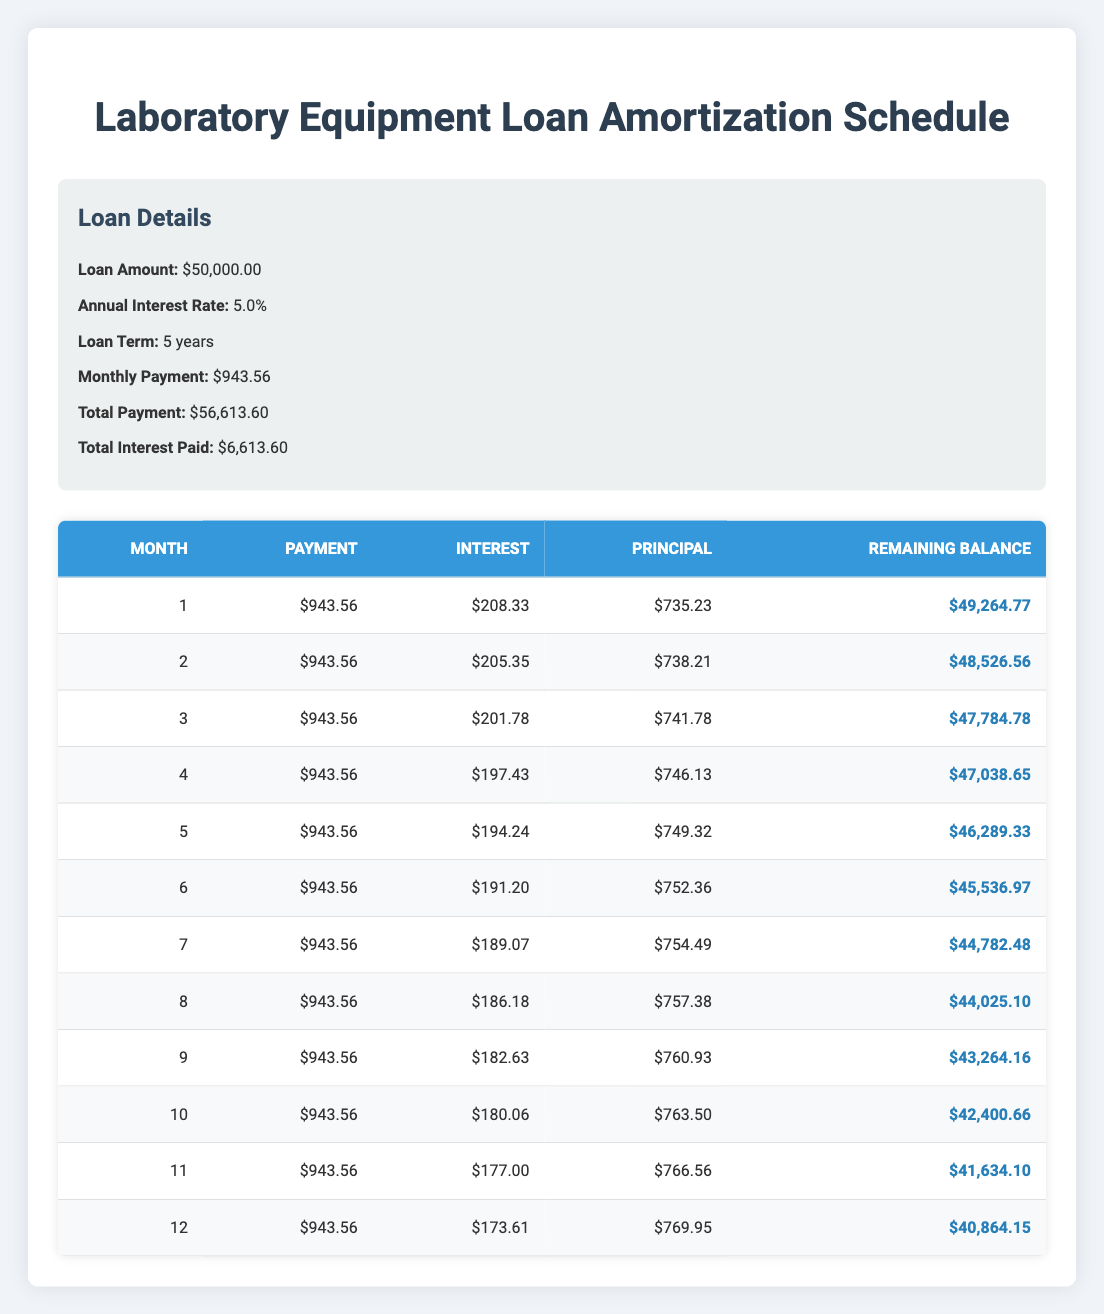What is the total loan amount? The total loan amount is specified in the loan details section, which states that the loan amount is 50,000.00.
Answer: 50,000.00 How much is the monthly payment? The monthly payment is listed in the loan details section, where it explicitly states that the monthly payment is 943.56.
Answer: 943.56 What was the interest paid in the 3rd month? Looking at the amortization schedule for the 3rd month, the interest paid is listed as 201.78.
Answer: 201.78 What is the remaining balance after the first payment? The remaining balance after the first payment can be found in the first row of the amortization schedule, which indicates it is 49,264.77.
Answer: 49,264.77 Is the principal paid in the 12th month greater than 700? Checking the principal paid in the 12th month from the schedule, it shows 769.95, which is greater than 700.
Answer: Yes What is the total interest paid over the first year? The total interest paid over the first year is the sum of the interest amounts for the first 12 months. Adding them up: 208.33 + 205.35 + 201.78 + 197.43 + 194.24 + 191.20 + 189.07 + 186.18 + 182.63 + 180.06 + 177.00 + 173.61 = 2,150.21.
Answer: 2,150.21 What is the average monthly payment over the 5 years? The average monthly payment is simply the total payment divided by the number of payments. Total payment is 56,613.60, and over 60 months, that is 56,613.60 / 60 = 943.56, which matches the monthly payment listed.
Answer: 943.56 How much of the initial loan amount is remaining after 6 months? To find the remaining loan balance after 6 months, we refer to the amortization schedule, which indicates that the remaining balance after 6 months is 45,536.97.
Answer: 45,536.97 Did the principal paid in the last month exceed the interest paid that month? In the last month (12th month), the principal paid is 769.95 and the interest paid is 173.61. Since 769.95 is greater than 173.61, the answer is yes.
Answer: Yes 